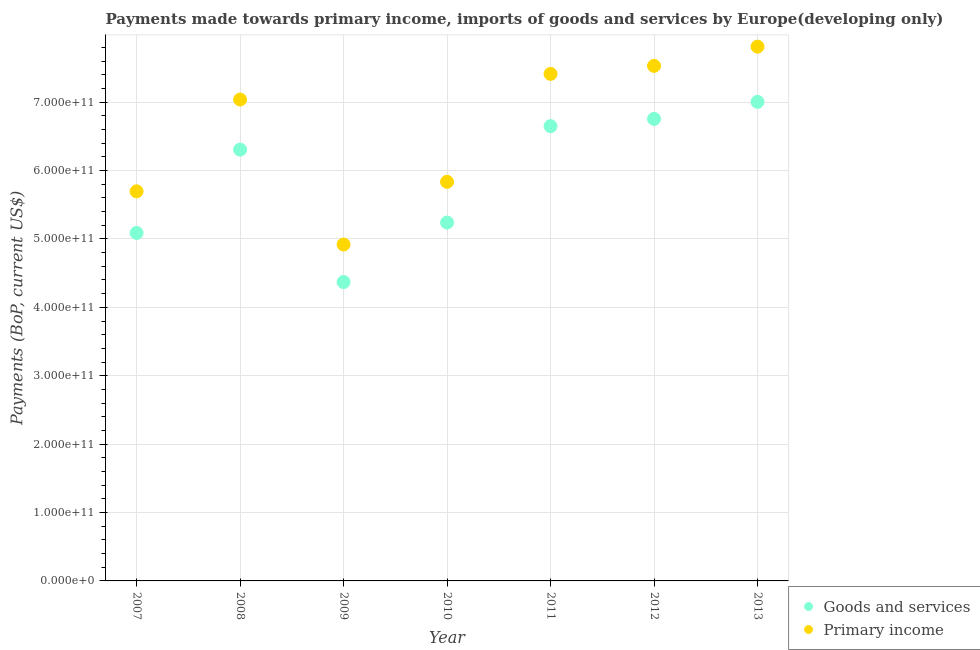What is the payments made towards primary income in 2007?
Offer a terse response. 5.70e+11. Across all years, what is the maximum payments made towards goods and services?
Ensure brevity in your answer.  7.00e+11. Across all years, what is the minimum payments made towards primary income?
Provide a succinct answer. 4.92e+11. What is the total payments made towards goods and services in the graph?
Your answer should be compact. 4.14e+12. What is the difference between the payments made towards primary income in 2008 and that in 2011?
Your response must be concise. -3.75e+1. What is the difference between the payments made towards primary income in 2010 and the payments made towards goods and services in 2009?
Offer a very short reply. 1.47e+11. What is the average payments made towards goods and services per year?
Your answer should be compact. 5.92e+11. In the year 2012, what is the difference between the payments made towards primary income and payments made towards goods and services?
Ensure brevity in your answer.  7.75e+1. In how many years, is the payments made towards primary income greater than 80000000000 US$?
Offer a terse response. 7. What is the ratio of the payments made towards primary income in 2008 to that in 2011?
Offer a terse response. 0.95. Is the payments made towards goods and services in 2008 less than that in 2011?
Offer a very short reply. Yes. What is the difference between the highest and the second highest payments made towards goods and services?
Offer a very short reply. 2.49e+1. What is the difference between the highest and the lowest payments made towards goods and services?
Give a very brief answer. 2.63e+11. Is the payments made towards primary income strictly greater than the payments made towards goods and services over the years?
Make the answer very short. Yes. How many dotlines are there?
Your answer should be compact. 2. What is the difference between two consecutive major ticks on the Y-axis?
Offer a terse response. 1.00e+11. Are the values on the major ticks of Y-axis written in scientific E-notation?
Keep it short and to the point. Yes. Where does the legend appear in the graph?
Ensure brevity in your answer.  Bottom right. How many legend labels are there?
Give a very brief answer. 2. What is the title of the graph?
Your response must be concise. Payments made towards primary income, imports of goods and services by Europe(developing only). Does "Under-5(female)" appear as one of the legend labels in the graph?
Ensure brevity in your answer.  No. What is the label or title of the X-axis?
Keep it short and to the point. Year. What is the label or title of the Y-axis?
Provide a short and direct response. Payments (BoP, current US$). What is the Payments (BoP, current US$) in Goods and services in 2007?
Offer a terse response. 5.09e+11. What is the Payments (BoP, current US$) in Primary income in 2007?
Give a very brief answer. 5.70e+11. What is the Payments (BoP, current US$) in Goods and services in 2008?
Your answer should be compact. 6.31e+11. What is the Payments (BoP, current US$) of Primary income in 2008?
Offer a terse response. 7.04e+11. What is the Payments (BoP, current US$) of Goods and services in 2009?
Your answer should be compact. 4.37e+11. What is the Payments (BoP, current US$) of Primary income in 2009?
Offer a very short reply. 4.92e+11. What is the Payments (BoP, current US$) of Goods and services in 2010?
Your response must be concise. 5.24e+11. What is the Payments (BoP, current US$) in Primary income in 2010?
Give a very brief answer. 5.84e+11. What is the Payments (BoP, current US$) of Goods and services in 2011?
Offer a very short reply. 6.65e+11. What is the Payments (BoP, current US$) of Primary income in 2011?
Keep it short and to the point. 7.41e+11. What is the Payments (BoP, current US$) of Goods and services in 2012?
Your answer should be very brief. 6.76e+11. What is the Payments (BoP, current US$) of Primary income in 2012?
Ensure brevity in your answer.  7.53e+11. What is the Payments (BoP, current US$) in Goods and services in 2013?
Provide a short and direct response. 7.00e+11. What is the Payments (BoP, current US$) in Primary income in 2013?
Your answer should be compact. 7.81e+11. Across all years, what is the maximum Payments (BoP, current US$) in Goods and services?
Keep it short and to the point. 7.00e+11. Across all years, what is the maximum Payments (BoP, current US$) in Primary income?
Offer a terse response. 7.81e+11. Across all years, what is the minimum Payments (BoP, current US$) of Goods and services?
Offer a very short reply. 4.37e+11. Across all years, what is the minimum Payments (BoP, current US$) in Primary income?
Your answer should be very brief. 4.92e+11. What is the total Payments (BoP, current US$) in Goods and services in the graph?
Your response must be concise. 4.14e+12. What is the total Payments (BoP, current US$) of Primary income in the graph?
Offer a very short reply. 4.62e+12. What is the difference between the Payments (BoP, current US$) of Goods and services in 2007 and that in 2008?
Keep it short and to the point. -1.22e+11. What is the difference between the Payments (BoP, current US$) of Primary income in 2007 and that in 2008?
Your response must be concise. -1.34e+11. What is the difference between the Payments (BoP, current US$) of Goods and services in 2007 and that in 2009?
Give a very brief answer. 7.18e+1. What is the difference between the Payments (BoP, current US$) in Primary income in 2007 and that in 2009?
Keep it short and to the point. 7.78e+1. What is the difference between the Payments (BoP, current US$) in Goods and services in 2007 and that in 2010?
Your answer should be compact. -1.52e+1. What is the difference between the Payments (BoP, current US$) of Primary income in 2007 and that in 2010?
Your answer should be very brief. -1.39e+1. What is the difference between the Payments (BoP, current US$) of Goods and services in 2007 and that in 2011?
Your answer should be compact. -1.56e+11. What is the difference between the Payments (BoP, current US$) in Primary income in 2007 and that in 2011?
Make the answer very short. -1.72e+11. What is the difference between the Payments (BoP, current US$) of Goods and services in 2007 and that in 2012?
Give a very brief answer. -1.67e+11. What is the difference between the Payments (BoP, current US$) of Primary income in 2007 and that in 2012?
Your answer should be very brief. -1.83e+11. What is the difference between the Payments (BoP, current US$) of Goods and services in 2007 and that in 2013?
Your response must be concise. -1.92e+11. What is the difference between the Payments (BoP, current US$) in Primary income in 2007 and that in 2013?
Give a very brief answer. -2.12e+11. What is the difference between the Payments (BoP, current US$) in Goods and services in 2008 and that in 2009?
Offer a very short reply. 1.94e+11. What is the difference between the Payments (BoP, current US$) in Primary income in 2008 and that in 2009?
Ensure brevity in your answer.  2.12e+11. What is the difference between the Payments (BoP, current US$) in Goods and services in 2008 and that in 2010?
Your answer should be very brief. 1.07e+11. What is the difference between the Payments (BoP, current US$) in Primary income in 2008 and that in 2010?
Your answer should be very brief. 1.20e+11. What is the difference between the Payments (BoP, current US$) of Goods and services in 2008 and that in 2011?
Provide a short and direct response. -3.43e+1. What is the difference between the Payments (BoP, current US$) of Primary income in 2008 and that in 2011?
Provide a short and direct response. -3.75e+1. What is the difference between the Payments (BoP, current US$) of Goods and services in 2008 and that in 2012?
Offer a terse response. -4.49e+1. What is the difference between the Payments (BoP, current US$) of Primary income in 2008 and that in 2012?
Offer a terse response. -4.92e+1. What is the difference between the Payments (BoP, current US$) in Goods and services in 2008 and that in 2013?
Your response must be concise. -6.98e+1. What is the difference between the Payments (BoP, current US$) of Primary income in 2008 and that in 2013?
Your response must be concise. -7.73e+1. What is the difference between the Payments (BoP, current US$) in Goods and services in 2009 and that in 2010?
Offer a very short reply. -8.70e+1. What is the difference between the Payments (BoP, current US$) of Primary income in 2009 and that in 2010?
Your answer should be very brief. -9.16e+1. What is the difference between the Payments (BoP, current US$) in Goods and services in 2009 and that in 2011?
Your answer should be very brief. -2.28e+11. What is the difference between the Payments (BoP, current US$) of Primary income in 2009 and that in 2011?
Your response must be concise. -2.49e+11. What is the difference between the Payments (BoP, current US$) in Goods and services in 2009 and that in 2012?
Offer a terse response. -2.39e+11. What is the difference between the Payments (BoP, current US$) of Primary income in 2009 and that in 2012?
Make the answer very short. -2.61e+11. What is the difference between the Payments (BoP, current US$) in Goods and services in 2009 and that in 2013?
Keep it short and to the point. -2.63e+11. What is the difference between the Payments (BoP, current US$) of Primary income in 2009 and that in 2013?
Provide a succinct answer. -2.89e+11. What is the difference between the Payments (BoP, current US$) of Goods and services in 2010 and that in 2011?
Offer a terse response. -1.41e+11. What is the difference between the Payments (BoP, current US$) in Primary income in 2010 and that in 2011?
Make the answer very short. -1.58e+11. What is the difference between the Payments (BoP, current US$) of Goods and services in 2010 and that in 2012?
Your answer should be very brief. -1.52e+11. What is the difference between the Payments (BoP, current US$) of Primary income in 2010 and that in 2012?
Make the answer very short. -1.70e+11. What is the difference between the Payments (BoP, current US$) of Goods and services in 2010 and that in 2013?
Give a very brief answer. -1.76e+11. What is the difference between the Payments (BoP, current US$) in Primary income in 2010 and that in 2013?
Make the answer very short. -1.98e+11. What is the difference between the Payments (BoP, current US$) of Goods and services in 2011 and that in 2012?
Ensure brevity in your answer.  -1.06e+1. What is the difference between the Payments (BoP, current US$) in Primary income in 2011 and that in 2012?
Your response must be concise. -1.17e+1. What is the difference between the Payments (BoP, current US$) of Goods and services in 2011 and that in 2013?
Provide a succinct answer. -3.55e+1. What is the difference between the Payments (BoP, current US$) in Primary income in 2011 and that in 2013?
Keep it short and to the point. -3.98e+1. What is the difference between the Payments (BoP, current US$) of Goods and services in 2012 and that in 2013?
Provide a short and direct response. -2.49e+1. What is the difference between the Payments (BoP, current US$) of Primary income in 2012 and that in 2013?
Ensure brevity in your answer.  -2.81e+1. What is the difference between the Payments (BoP, current US$) of Goods and services in 2007 and the Payments (BoP, current US$) of Primary income in 2008?
Your answer should be very brief. -1.95e+11. What is the difference between the Payments (BoP, current US$) of Goods and services in 2007 and the Payments (BoP, current US$) of Primary income in 2009?
Your answer should be very brief. 1.69e+1. What is the difference between the Payments (BoP, current US$) in Goods and services in 2007 and the Payments (BoP, current US$) in Primary income in 2010?
Your answer should be compact. -7.48e+1. What is the difference between the Payments (BoP, current US$) of Goods and services in 2007 and the Payments (BoP, current US$) of Primary income in 2011?
Keep it short and to the point. -2.33e+11. What is the difference between the Payments (BoP, current US$) of Goods and services in 2007 and the Payments (BoP, current US$) of Primary income in 2012?
Your response must be concise. -2.44e+11. What is the difference between the Payments (BoP, current US$) in Goods and services in 2007 and the Payments (BoP, current US$) in Primary income in 2013?
Your answer should be very brief. -2.72e+11. What is the difference between the Payments (BoP, current US$) in Goods and services in 2008 and the Payments (BoP, current US$) in Primary income in 2009?
Your response must be concise. 1.39e+11. What is the difference between the Payments (BoP, current US$) in Goods and services in 2008 and the Payments (BoP, current US$) in Primary income in 2010?
Give a very brief answer. 4.71e+1. What is the difference between the Payments (BoP, current US$) of Goods and services in 2008 and the Payments (BoP, current US$) of Primary income in 2011?
Ensure brevity in your answer.  -1.11e+11. What is the difference between the Payments (BoP, current US$) in Goods and services in 2008 and the Payments (BoP, current US$) in Primary income in 2012?
Offer a terse response. -1.22e+11. What is the difference between the Payments (BoP, current US$) in Goods and services in 2008 and the Payments (BoP, current US$) in Primary income in 2013?
Your answer should be very brief. -1.51e+11. What is the difference between the Payments (BoP, current US$) of Goods and services in 2009 and the Payments (BoP, current US$) of Primary income in 2010?
Your answer should be very brief. -1.47e+11. What is the difference between the Payments (BoP, current US$) in Goods and services in 2009 and the Payments (BoP, current US$) in Primary income in 2011?
Provide a succinct answer. -3.04e+11. What is the difference between the Payments (BoP, current US$) in Goods and services in 2009 and the Payments (BoP, current US$) in Primary income in 2012?
Give a very brief answer. -3.16e+11. What is the difference between the Payments (BoP, current US$) in Goods and services in 2009 and the Payments (BoP, current US$) in Primary income in 2013?
Your answer should be very brief. -3.44e+11. What is the difference between the Payments (BoP, current US$) in Goods and services in 2010 and the Payments (BoP, current US$) in Primary income in 2011?
Offer a very short reply. -2.17e+11. What is the difference between the Payments (BoP, current US$) of Goods and services in 2010 and the Payments (BoP, current US$) of Primary income in 2012?
Keep it short and to the point. -2.29e+11. What is the difference between the Payments (BoP, current US$) of Goods and services in 2010 and the Payments (BoP, current US$) of Primary income in 2013?
Make the answer very short. -2.57e+11. What is the difference between the Payments (BoP, current US$) in Goods and services in 2011 and the Payments (BoP, current US$) in Primary income in 2012?
Your response must be concise. -8.81e+1. What is the difference between the Payments (BoP, current US$) in Goods and services in 2011 and the Payments (BoP, current US$) in Primary income in 2013?
Make the answer very short. -1.16e+11. What is the difference between the Payments (BoP, current US$) of Goods and services in 2012 and the Payments (BoP, current US$) of Primary income in 2013?
Your answer should be compact. -1.06e+11. What is the average Payments (BoP, current US$) of Goods and services per year?
Your response must be concise. 5.92e+11. What is the average Payments (BoP, current US$) of Primary income per year?
Make the answer very short. 6.61e+11. In the year 2007, what is the difference between the Payments (BoP, current US$) in Goods and services and Payments (BoP, current US$) in Primary income?
Provide a succinct answer. -6.09e+1. In the year 2008, what is the difference between the Payments (BoP, current US$) of Goods and services and Payments (BoP, current US$) of Primary income?
Ensure brevity in your answer.  -7.32e+1. In the year 2009, what is the difference between the Payments (BoP, current US$) of Goods and services and Payments (BoP, current US$) of Primary income?
Give a very brief answer. -5.49e+1. In the year 2010, what is the difference between the Payments (BoP, current US$) in Goods and services and Payments (BoP, current US$) in Primary income?
Offer a very short reply. -5.95e+1. In the year 2011, what is the difference between the Payments (BoP, current US$) of Goods and services and Payments (BoP, current US$) of Primary income?
Give a very brief answer. -7.64e+1. In the year 2012, what is the difference between the Payments (BoP, current US$) of Goods and services and Payments (BoP, current US$) of Primary income?
Your answer should be compact. -7.75e+1. In the year 2013, what is the difference between the Payments (BoP, current US$) of Goods and services and Payments (BoP, current US$) of Primary income?
Offer a terse response. -8.08e+1. What is the ratio of the Payments (BoP, current US$) of Goods and services in 2007 to that in 2008?
Give a very brief answer. 0.81. What is the ratio of the Payments (BoP, current US$) of Primary income in 2007 to that in 2008?
Make the answer very short. 0.81. What is the ratio of the Payments (BoP, current US$) in Goods and services in 2007 to that in 2009?
Ensure brevity in your answer.  1.16. What is the ratio of the Payments (BoP, current US$) of Primary income in 2007 to that in 2009?
Offer a very short reply. 1.16. What is the ratio of the Payments (BoP, current US$) of Goods and services in 2007 to that in 2010?
Make the answer very short. 0.97. What is the ratio of the Payments (BoP, current US$) of Primary income in 2007 to that in 2010?
Your response must be concise. 0.98. What is the ratio of the Payments (BoP, current US$) of Goods and services in 2007 to that in 2011?
Keep it short and to the point. 0.77. What is the ratio of the Payments (BoP, current US$) in Primary income in 2007 to that in 2011?
Offer a terse response. 0.77. What is the ratio of the Payments (BoP, current US$) in Goods and services in 2007 to that in 2012?
Provide a succinct answer. 0.75. What is the ratio of the Payments (BoP, current US$) in Primary income in 2007 to that in 2012?
Your answer should be compact. 0.76. What is the ratio of the Payments (BoP, current US$) of Goods and services in 2007 to that in 2013?
Your answer should be very brief. 0.73. What is the ratio of the Payments (BoP, current US$) in Primary income in 2007 to that in 2013?
Provide a short and direct response. 0.73. What is the ratio of the Payments (BoP, current US$) of Goods and services in 2008 to that in 2009?
Offer a terse response. 1.44. What is the ratio of the Payments (BoP, current US$) in Primary income in 2008 to that in 2009?
Provide a short and direct response. 1.43. What is the ratio of the Payments (BoP, current US$) of Goods and services in 2008 to that in 2010?
Offer a terse response. 1.2. What is the ratio of the Payments (BoP, current US$) of Primary income in 2008 to that in 2010?
Your response must be concise. 1.21. What is the ratio of the Payments (BoP, current US$) in Goods and services in 2008 to that in 2011?
Your answer should be very brief. 0.95. What is the ratio of the Payments (BoP, current US$) in Primary income in 2008 to that in 2011?
Offer a terse response. 0.95. What is the ratio of the Payments (BoP, current US$) of Goods and services in 2008 to that in 2012?
Offer a very short reply. 0.93. What is the ratio of the Payments (BoP, current US$) in Primary income in 2008 to that in 2012?
Offer a terse response. 0.93. What is the ratio of the Payments (BoP, current US$) in Goods and services in 2008 to that in 2013?
Keep it short and to the point. 0.9. What is the ratio of the Payments (BoP, current US$) of Primary income in 2008 to that in 2013?
Provide a succinct answer. 0.9. What is the ratio of the Payments (BoP, current US$) of Goods and services in 2009 to that in 2010?
Provide a succinct answer. 0.83. What is the ratio of the Payments (BoP, current US$) in Primary income in 2009 to that in 2010?
Make the answer very short. 0.84. What is the ratio of the Payments (BoP, current US$) in Goods and services in 2009 to that in 2011?
Offer a terse response. 0.66. What is the ratio of the Payments (BoP, current US$) of Primary income in 2009 to that in 2011?
Give a very brief answer. 0.66. What is the ratio of the Payments (BoP, current US$) in Goods and services in 2009 to that in 2012?
Keep it short and to the point. 0.65. What is the ratio of the Payments (BoP, current US$) in Primary income in 2009 to that in 2012?
Keep it short and to the point. 0.65. What is the ratio of the Payments (BoP, current US$) in Goods and services in 2009 to that in 2013?
Keep it short and to the point. 0.62. What is the ratio of the Payments (BoP, current US$) of Primary income in 2009 to that in 2013?
Offer a very short reply. 0.63. What is the ratio of the Payments (BoP, current US$) in Goods and services in 2010 to that in 2011?
Your answer should be compact. 0.79. What is the ratio of the Payments (BoP, current US$) of Primary income in 2010 to that in 2011?
Your response must be concise. 0.79. What is the ratio of the Payments (BoP, current US$) in Goods and services in 2010 to that in 2012?
Provide a short and direct response. 0.78. What is the ratio of the Payments (BoP, current US$) of Primary income in 2010 to that in 2012?
Your answer should be compact. 0.77. What is the ratio of the Payments (BoP, current US$) in Goods and services in 2010 to that in 2013?
Make the answer very short. 0.75. What is the ratio of the Payments (BoP, current US$) of Primary income in 2010 to that in 2013?
Offer a terse response. 0.75. What is the ratio of the Payments (BoP, current US$) of Goods and services in 2011 to that in 2012?
Provide a succinct answer. 0.98. What is the ratio of the Payments (BoP, current US$) in Primary income in 2011 to that in 2012?
Your response must be concise. 0.98. What is the ratio of the Payments (BoP, current US$) of Goods and services in 2011 to that in 2013?
Make the answer very short. 0.95. What is the ratio of the Payments (BoP, current US$) in Primary income in 2011 to that in 2013?
Give a very brief answer. 0.95. What is the ratio of the Payments (BoP, current US$) of Goods and services in 2012 to that in 2013?
Your answer should be very brief. 0.96. What is the ratio of the Payments (BoP, current US$) in Primary income in 2012 to that in 2013?
Ensure brevity in your answer.  0.96. What is the difference between the highest and the second highest Payments (BoP, current US$) of Goods and services?
Your answer should be compact. 2.49e+1. What is the difference between the highest and the second highest Payments (BoP, current US$) of Primary income?
Ensure brevity in your answer.  2.81e+1. What is the difference between the highest and the lowest Payments (BoP, current US$) of Goods and services?
Keep it short and to the point. 2.63e+11. What is the difference between the highest and the lowest Payments (BoP, current US$) in Primary income?
Your answer should be very brief. 2.89e+11. 